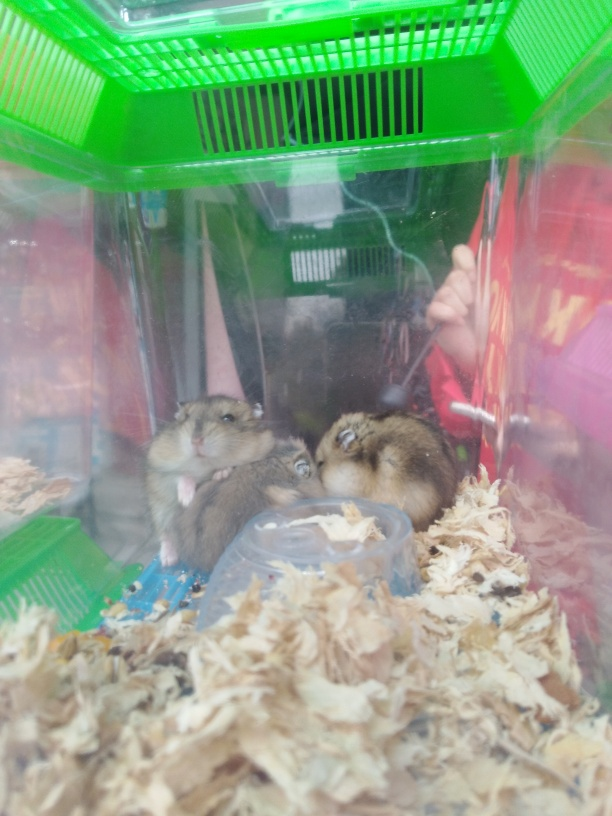Can you tell me what kind of animals these are? Based on their size, fur pattern, and overall shape, these animals are most likely hamsters, which are small rodents commonly kept as household pets. What should one consider when creating a habitat for hamsters? When creating a habitat for hamsters, it's important to include ample space for exploration, a comfortable and absorbent bedding for burrowing, a secure enclosure to prevent escape, consistent access to fresh water and a balanced diet, as well as toys and exercise accessories like a running wheel to keep them physically active and mentally stimulated. 